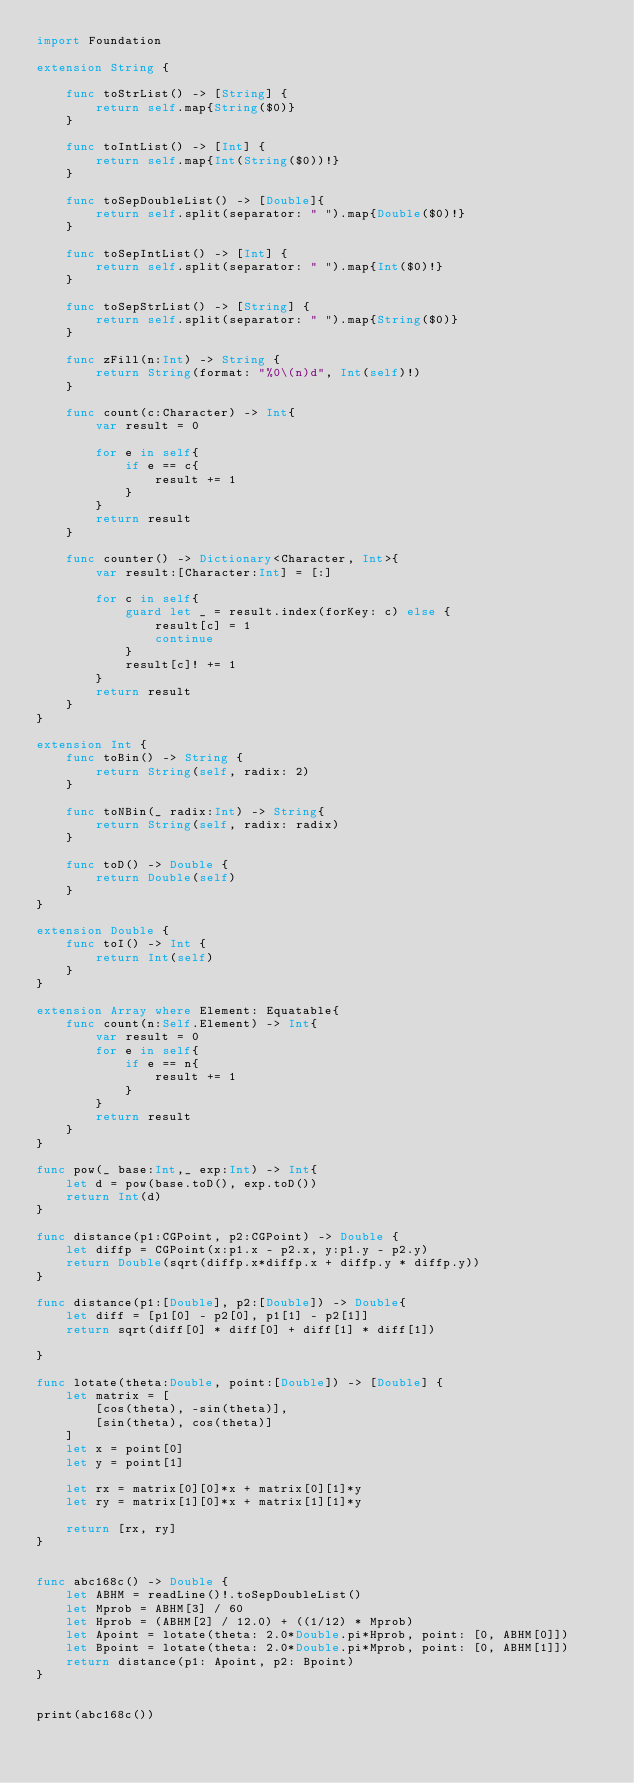Convert code to text. <code><loc_0><loc_0><loc_500><loc_500><_Swift_>import Foundation

extension String {
    
    func toStrList() -> [String] {
        return self.map{String($0)}
    }
    
    func toIntList() -> [Int] {
        return self.map{Int(String($0))!}
    }
    
    func toSepDoubleList() -> [Double]{
        return self.split(separator: " ").map{Double($0)!}
    }

    func toSepIntList() -> [Int] {
        return self.split(separator: " ").map{Int($0)!}
    }

    func toSepStrList() -> [String] {
        return self.split(separator: " ").map{String($0)}
    }
    
    func zFill(n:Int) -> String {
        return String(format: "%0\(n)d", Int(self)!)
    }
    
    func count(c:Character) -> Int{
        var result = 0

        for e in self{
            if e == c{
                result += 1
            }
        }
        return result
    }

    func counter() -> Dictionary<Character, Int>{
        var result:[Character:Int] = [:]
        
        for c in self{
            guard let _ = result.index(forKey: c) else {
                result[c] = 1
                continue
            }
            result[c]! += 1
        }
        return result
    }
}

extension Int {
    func toBin() -> String {
        return String(self, radix: 2)
    }
    
    func toNBin(_ radix:Int) -> String{
        return String(self, radix: radix)
    }
    
    func toD() -> Double {
        return Double(self)
    }
}

extension Double {
    func toI() -> Int {
        return Int(self)
    }
}

extension Array where Element: Equatable{
    func count(n:Self.Element) -> Int{
        var result = 0
        for e in self{
            if e == n{
                result += 1
            }
        }
        return result
    }
}

func pow(_ base:Int,_ exp:Int) -> Int{
    let d = pow(base.toD(), exp.toD())
    return Int(d)
}

func distance(p1:CGPoint, p2:CGPoint) -> Double {
    let diffp = CGPoint(x:p1.x - p2.x, y:p1.y - p2.y)
    return Double(sqrt(diffp.x*diffp.x + diffp.y * diffp.y))
}

func distance(p1:[Double], p2:[Double]) -> Double{
    let diff = [p1[0] - p2[0], p1[1] - p2[1]]
    return sqrt(diff[0] * diff[0] + diff[1] * diff[1])
    
}

func lotate(theta:Double, point:[Double]) -> [Double] {
    let matrix = [
        [cos(theta), -sin(theta)],
        [sin(theta), cos(theta)]
    ]
    let x = point[0]
    let y = point[1]
    
    let rx = matrix[0][0]*x + matrix[0][1]*y
    let ry = matrix[1][0]*x + matrix[1][1]*y
    
    return [rx, ry]
}


func abc168c() -> Double {
    let ABHM = readLine()!.toSepDoubleList()
    let Mprob = ABHM[3] / 60
    let Hprob = (ABHM[2] / 12.0) + ((1/12) * Mprob)
    let Apoint = lotate(theta: 2.0*Double.pi*Hprob, point: [0, ABHM[0]])
    let Bpoint = lotate(theta: 2.0*Double.pi*Mprob, point: [0, ABHM[1]])
    return distance(p1: Apoint, p2: Bpoint)
}


print(abc168c())

</code> 